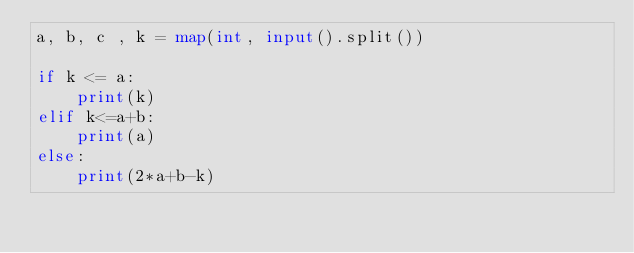Convert code to text. <code><loc_0><loc_0><loc_500><loc_500><_Python_>a, b, c , k = map(int, input().split())

if k <= a:
    print(k)
elif k<=a+b:
    print(a)
else:
    print(2*a+b-k)</code> 